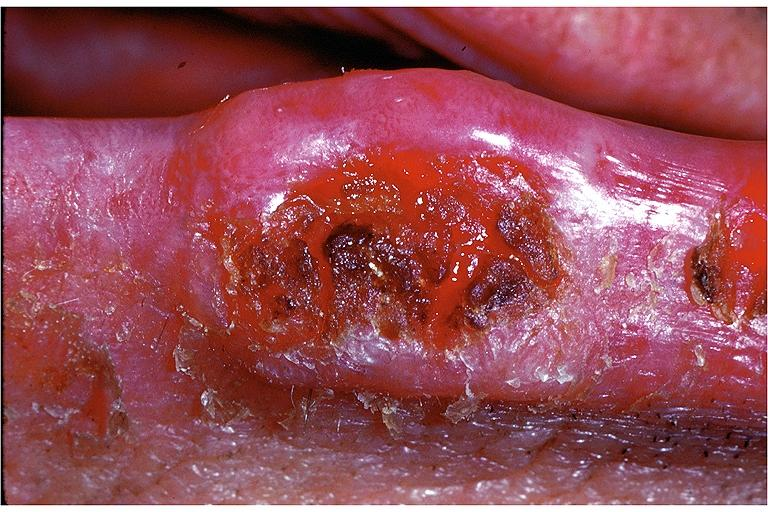what is present?
Answer the question using a single word or phrase. Oral 